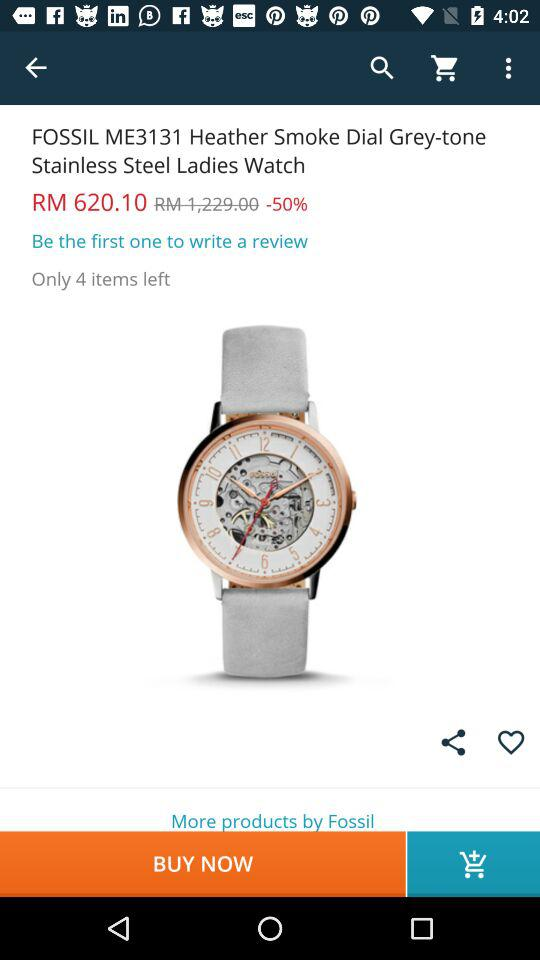How many items are left in stock?
Answer the question using a single word or phrase. 4 